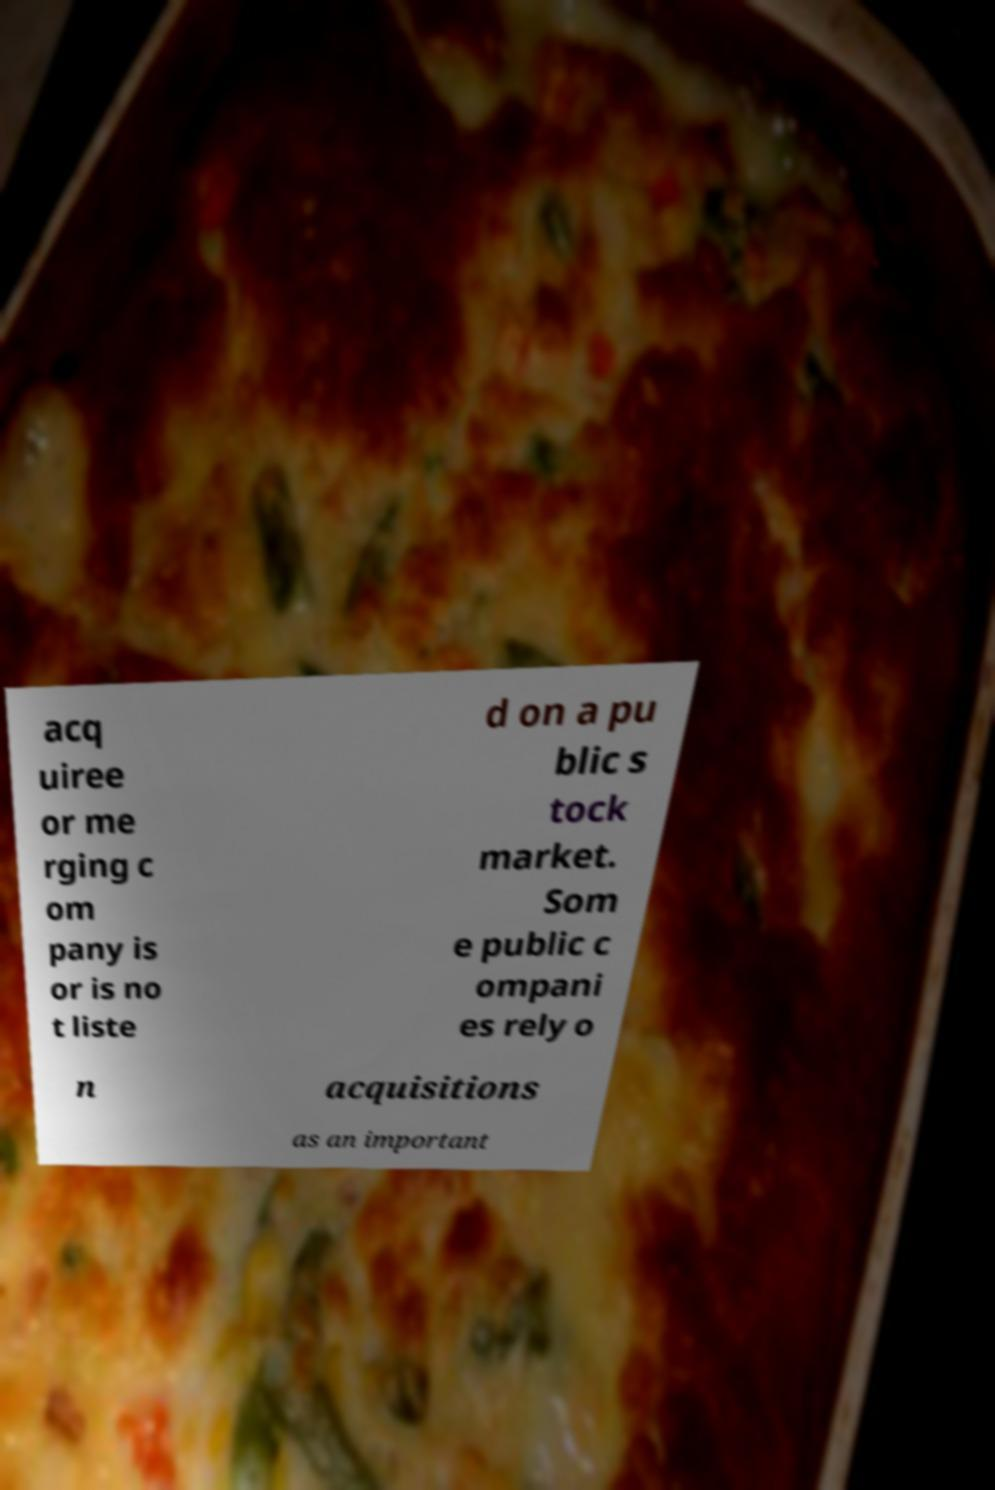What messages or text are displayed in this image? I need them in a readable, typed format. acq uiree or me rging c om pany is or is no t liste d on a pu blic s tock market. Som e public c ompani es rely o n acquisitions as an important 